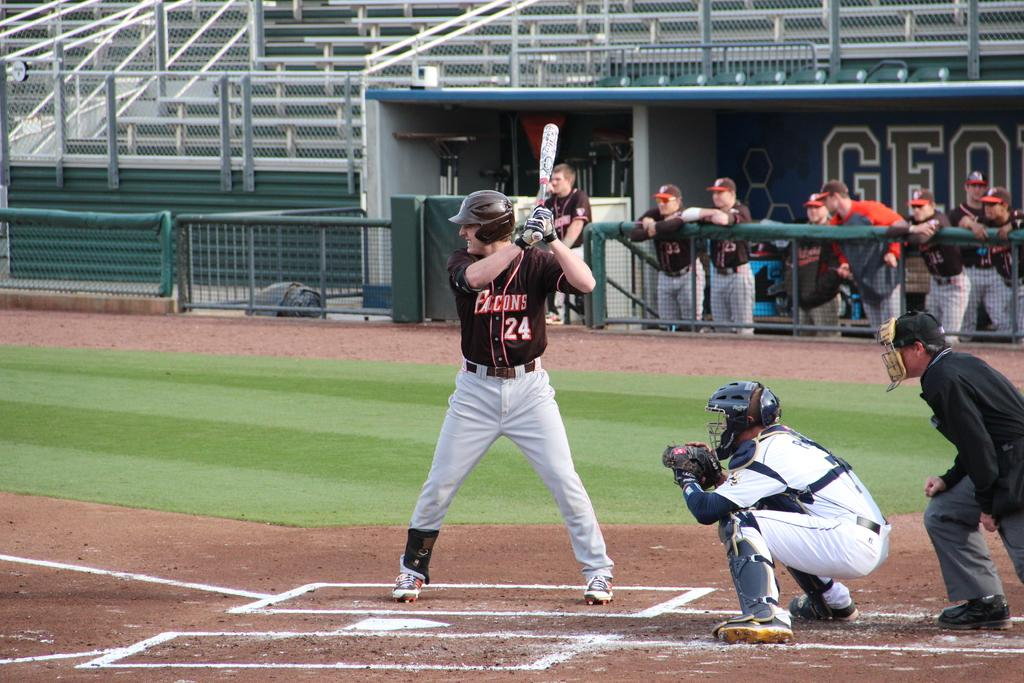<image>
Offer a succinct explanation of the picture presented. a baseball player up to bat wears a Falcons 24 jersey 